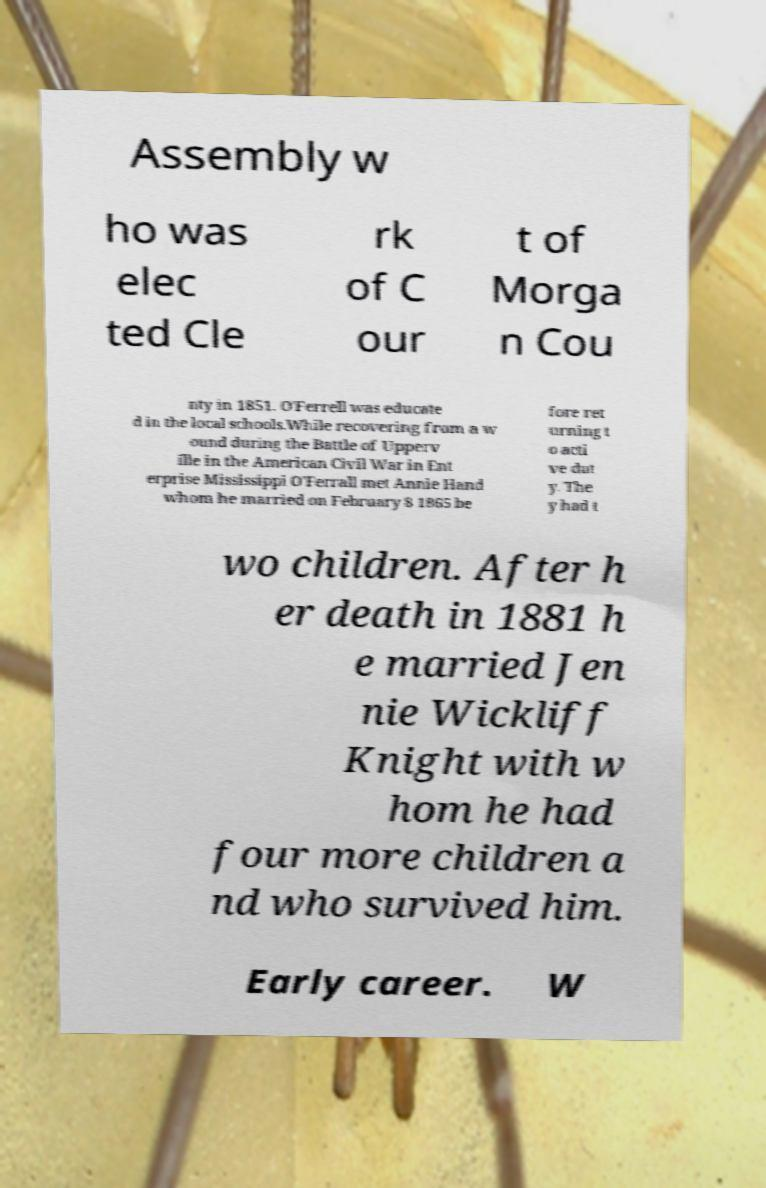Can you accurately transcribe the text from the provided image for me? Assembly w ho was elec ted Cle rk of C our t of Morga n Cou nty in 1851. O'Ferrell was educate d in the local schools.While recovering from a w ound during the Battle of Upperv ille in the American Civil War in Ent erprise Mississippi O'Ferrall met Annie Hand whom he married on February 8 1865 be fore ret urning t o acti ve dut y. The y had t wo children. After h er death in 1881 h e married Jen nie Wickliff Knight with w hom he had four more children a nd who survived him. Early career. W 